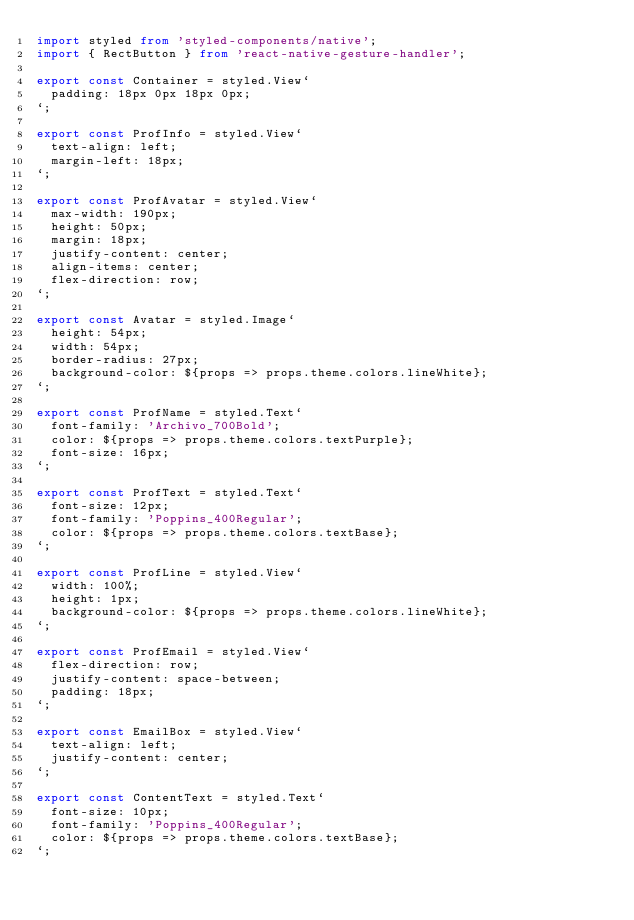<code> <loc_0><loc_0><loc_500><loc_500><_TypeScript_>import styled from 'styled-components/native';
import { RectButton } from 'react-native-gesture-handler';

export const Container = styled.View`
  padding: 18px 0px 18px 0px;
`;

export const ProfInfo = styled.View`
  text-align: left;
  margin-left: 18px;
`;

export const ProfAvatar = styled.View`
  max-width: 190px;
  height: 50px;
  margin: 18px;
  justify-content: center;
  align-items: center;
  flex-direction: row;
`;

export const Avatar = styled.Image`
  height: 54px;
  width: 54px;
  border-radius: 27px;
  background-color: ${props => props.theme.colors.lineWhite};
`;

export const ProfName = styled.Text`
  font-family: 'Archivo_700Bold';
  color: ${props => props.theme.colors.textPurple};
  font-size: 16px;
`;

export const ProfText = styled.Text`
  font-size: 12px;
  font-family: 'Poppins_400Regular';
  color: ${props => props.theme.colors.textBase};
`;

export const ProfLine = styled.View`
  width: 100%;
  height: 1px;
  background-color: ${props => props.theme.colors.lineWhite};
`;

export const ProfEmail = styled.View`
  flex-direction: row;
  justify-content: space-between;
  padding: 18px;
`;

export const EmailBox = styled.View`
  text-align: left;
  justify-content: center;
`;

export const ContentText = styled.Text`
  font-size: 10px;
  font-family: 'Poppins_400Regular';
  color: ${props => props.theme.colors.textBase};
`;
</code> 